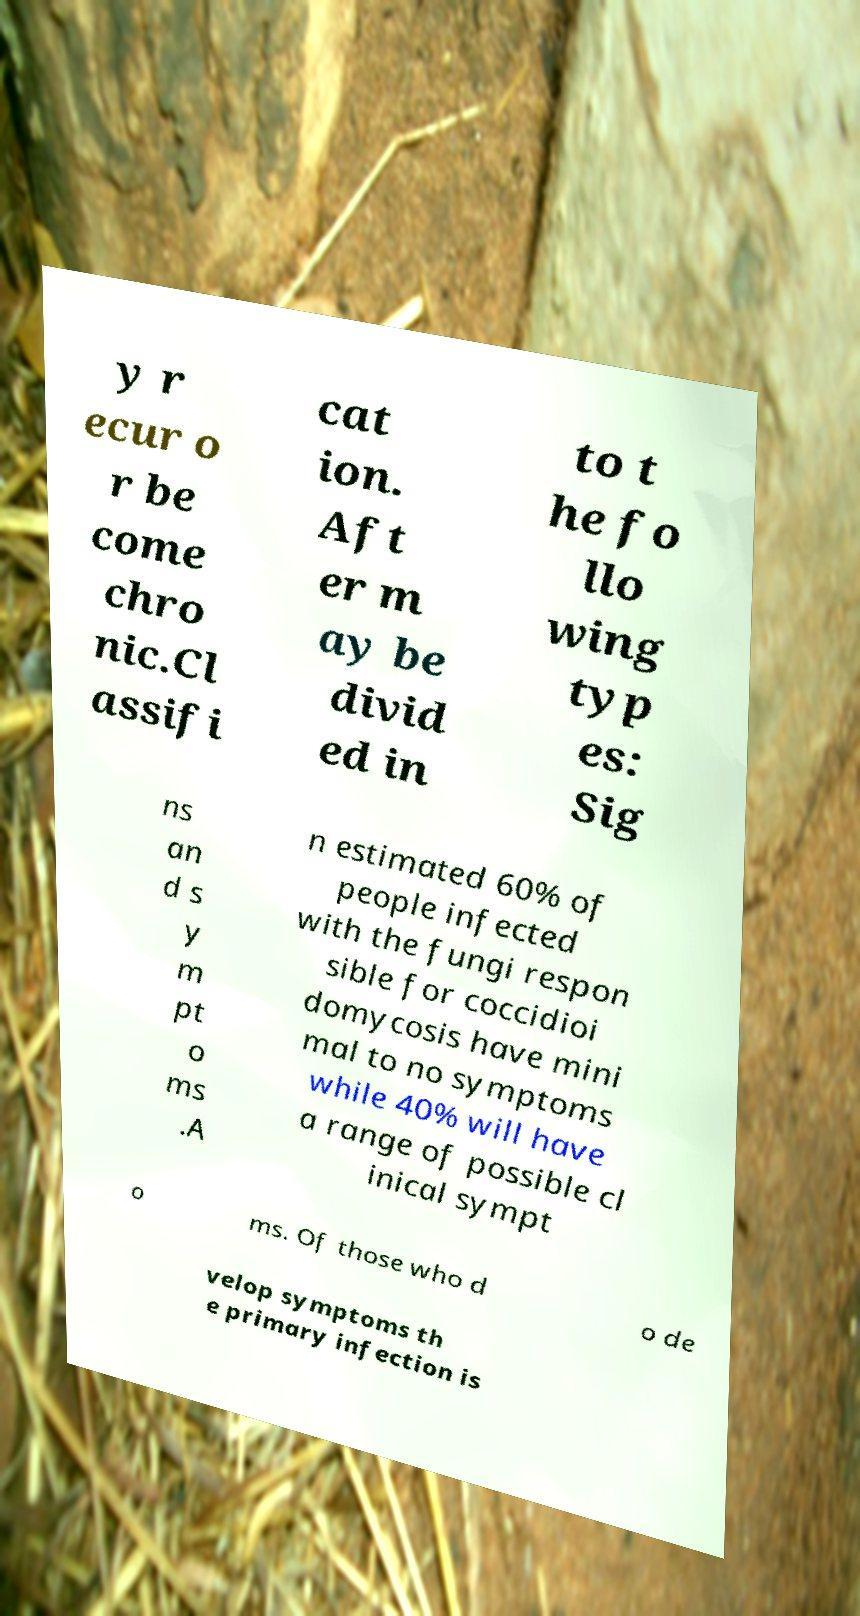For documentation purposes, I need the text within this image transcribed. Could you provide that? y r ecur o r be come chro nic.Cl assifi cat ion. Aft er m ay be divid ed in to t he fo llo wing typ es: Sig ns an d s y m pt o ms .A n estimated 60% of people infected with the fungi respon sible for coccidioi domycosis have mini mal to no symptoms while 40% will have a range of possible cl inical sympt o ms. Of those who d o de velop symptoms th e primary infection is 